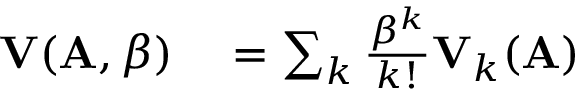Convert formula to latex. <formula><loc_0><loc_0><loc_500><loc_500>\begin{array} { r l } { V ( A , \beta ) } & = \sum _ { k } \frac { \beta ^ { k } } { k ! } V _ { k } ( A ) } \end{array}</formula> 